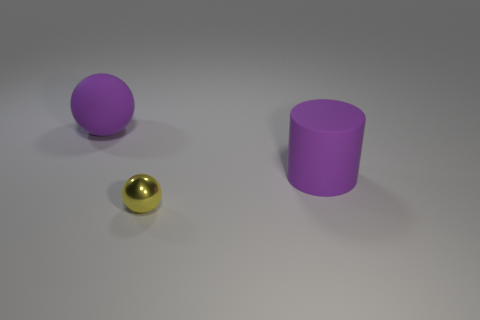Are there more tiny shiny balls that are to the left of the large rubber ball than yellow spheres?
Provide a succinct answer. No. How many yellow metal spheres are in front of the big matte object that is behind the purple rubber thing that is right of the big purple matte ball?
Provide a short and direct response. 1. Does the purple thing that is behind the large purple cylinder have the same shape as the yellow shiny object?
Give a very brief answer. Yes. What is the purple object that is on the right side of the yellow metallic sphere made of?
Your response must be concise. Rubber. The object that is behind the small yellow thing and right of the large purple ball has what shape?
Your response must be concise. Cylinder. What is the cylinder made of?
Offer a terse response. Rubber. What number of cylinders are either yellow metallic things or big rubber things?
Provide a short and direct response. 1. Is the tiny thing made of the same material as the large cylinder?
Keep it short and to the point. No. What size is the purple matte thing that is the same shape as the small yellow thing?
Your response must be concise. Large. There is a thing that is both to the left of the large cylinder and behind the small metallic object; what material is it?
Ensure brevity in your answer.  Rubber. 